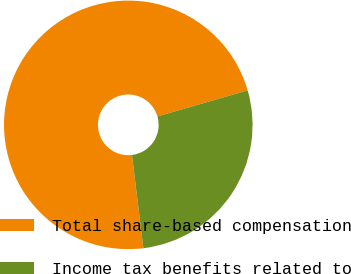<chart> <loc_0><loc_0><loc_500><loc_500><pie_chart><fcel>Total share-based compensation<fcel>Income tax benefits related to<nl><fcel>72.46%<fcel>27.54%<nl></chart> 